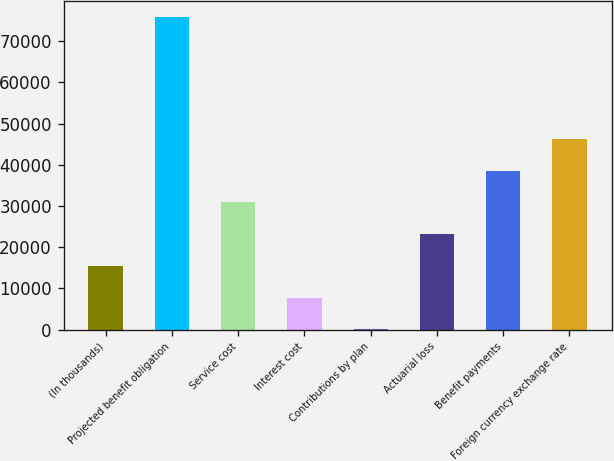Convert chart to OTSL. <chart><loc_0><loc_0><loc_500><loc_500><bar_chart><fcel>(In thousands)<fcel>Projected benefit obligation<fcel>Service cost<fcel>Interest cost<fcel>Contributions by plan<fcel>Actuarial loss<fcel>Benefit payments<fcel>Foreign currency exchange rate<nl><fcel>15471.8<fcel>75928<fcel>30862.6<fcel>7776.4<fcel>81<fcel>23167.2<fcel>38558<fcel>46253.4<nl></chart> 